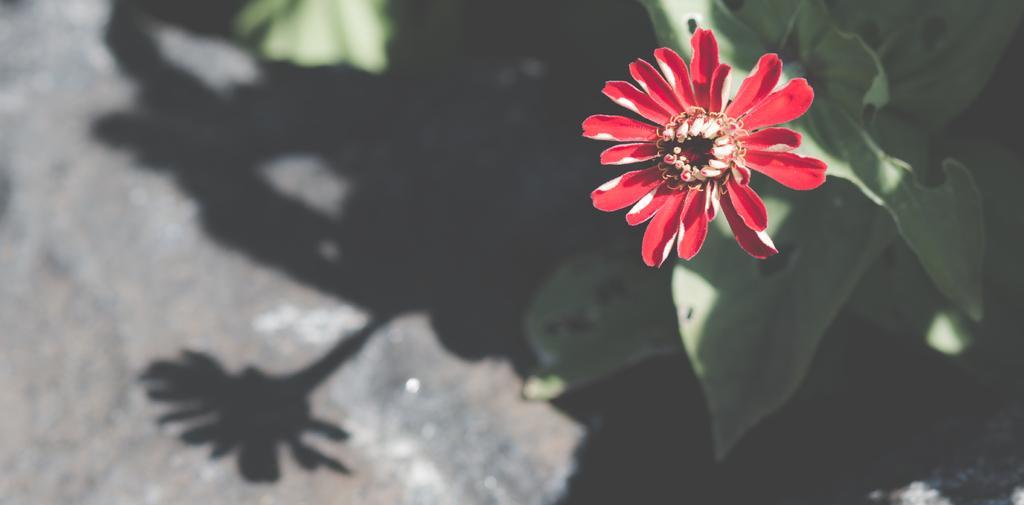Could you give a brief overview of what you see in this image? In this picture I can see there is a red color flower with few petals. There are few leaves, there is a shadow of the plant on the floor. 